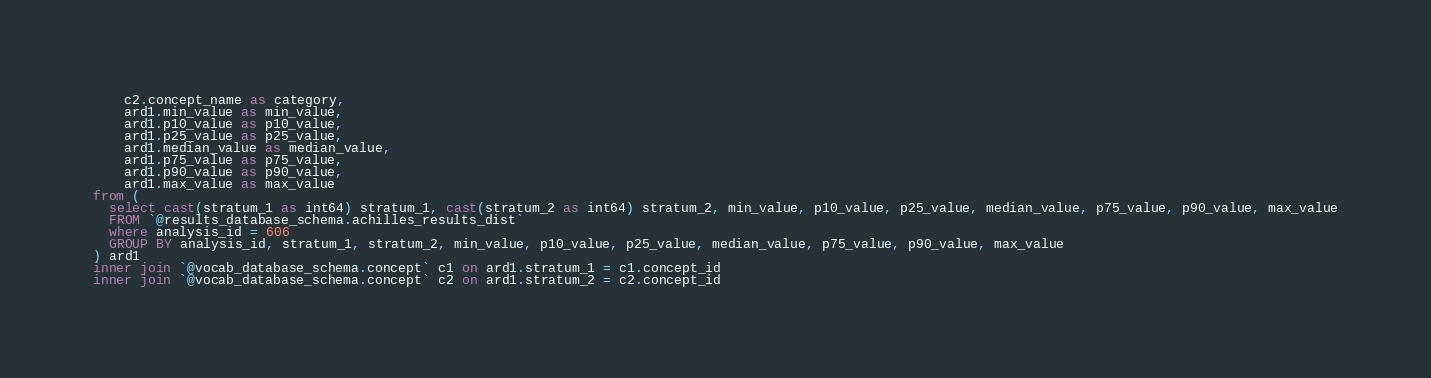<code> <loc_0><loc_0><loc_500><loc_500><_SQL_>    c2.concept_name as category,
  	ard1.min_value as min_value,
  	ard1.p10_value as p10_value,
  	ard1.p25_value as p25_value,
  	ard1.median_value as median_value,
  	ard1.p75_value as p75_value,
  	ard1.p90_value as p90_value,
  	ard1.max_value as max_value
from (
  select cast(stratum_1 as int64) stratum_1, cast(stratum_2 as int64) stratum_2, min_value, p10_value, p25_value, median_value, p75_value, p90_value, max_value
  FROM `@results_database_schema.achilles_results_dist`
  where analysis_id = 606
  GROUP BY analysis_id, stratum_1, stratum_2, min_value, p10_value, p25_value, median_value, p75_value, p90_value, max_value 
) ard1
inner join `@vocab_database_schema.concept` c1 on ard1.stratum_1 = c1.concept_id
inner join `@vocab_database_schema.concept` c2 on ard1.stratum_2 = c2.concept_id
</code> 